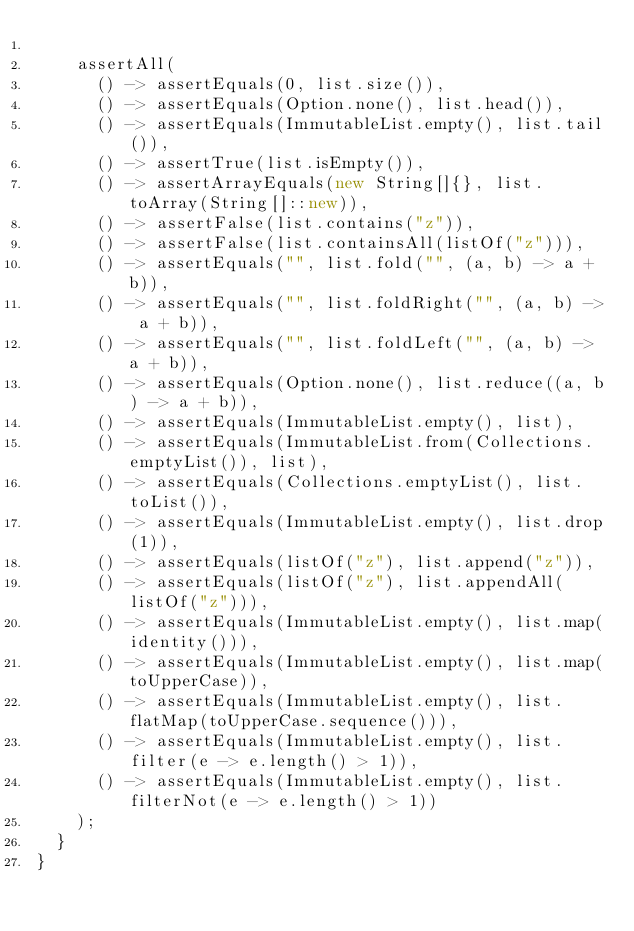Convert code to text. <code><loc_0><loc_0><loc_500><loc_500><_Java_>
    assertAll(
      () -> assertEquals(0, list.size()),
      () -> assertEquals(Option.none(), list.head()),
      () -> assertEquals(ImmutableList.empty(), list.tail()),
      () -> assertTrue(list.isEmpty()),
      () -> assertArrayEquals(new String[]{}, list.toArray(String[]::new)),
      () -> assertFalse(list.contains("z")),
      () -> assertFalse(list.containsAll(listOf("z"))),
      () -> assertEquals("", list.fold("", (a, b) -> a + b)),
      () -> assertEquals("", list.foldRight("", (a, b) -> a + b)),
      () -> assertEquals("", list.foldLeft("", (a, b) -> a + b)),
      () -> assertEquals(Option.none(), list.reduce((a, b) -> a + b)),
      () -> assertEquals(ImmutableList.empty(), list),
      () -> assertEquals(ImmutableList.from(Collections.emptyList()), list),
      () -> assertEquals(Collections.emptyList(), list.toList()),
      () -> assertEquals(ImmutableList.empty(), list.drop(1)),
      () -> assertEquals(listOf("z"), list.append("z")),
      () -> assertEquals(listOf("z"), list.appendAll(listOf("z"))),
      () -> assertEquals(ImmutableList.empty(), list.map(identity())),
      () -> assertEquals(ImmutableList.empty(), list.map(toUpperCase)),
      () -> assertEquals(ImmutableList.empty(), list.flatMap(toUpperCase.sequence())),
      () -> assertEquals(ImmutableList.empty(), list.filter(e -> e.length() > 1)),
      () -> assertEquals(ImmutableList.empty(), list.filterNot(e -> e.length() > 1))
    );
  }
}
</code> 